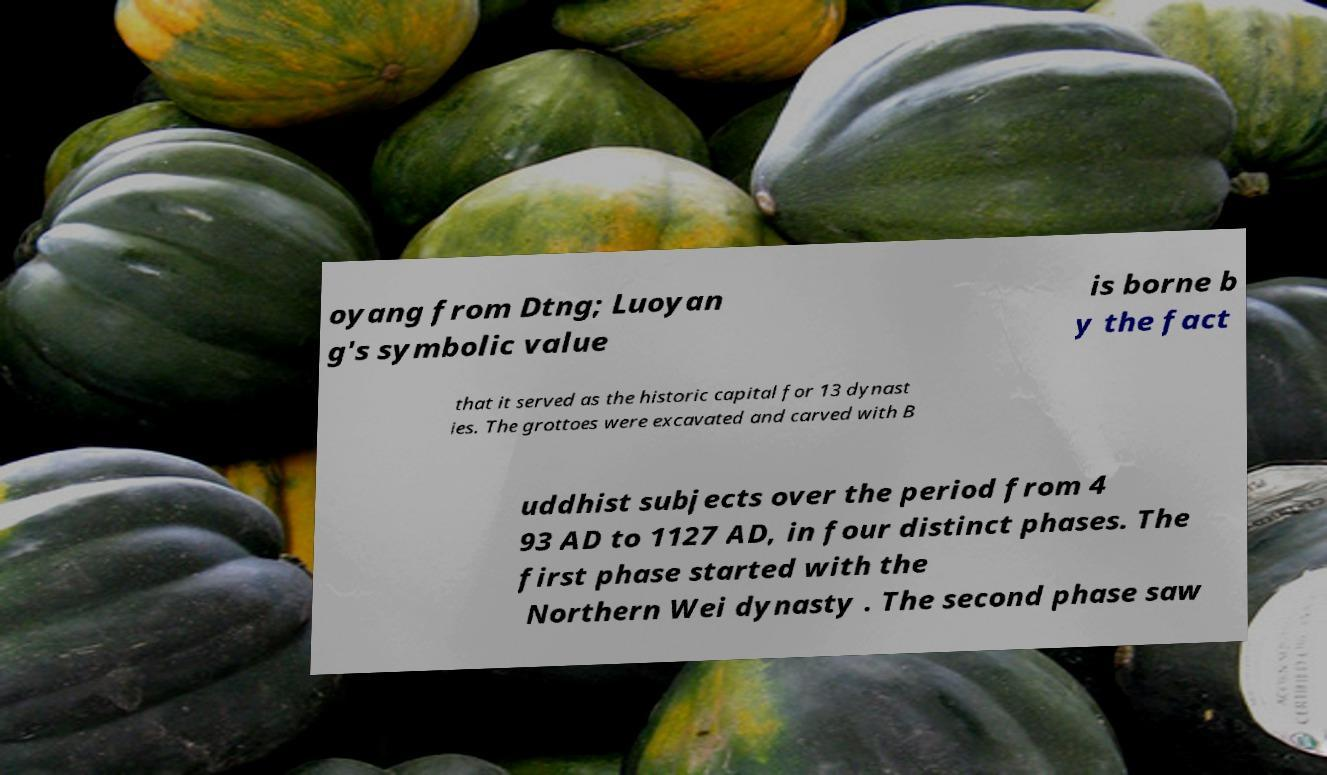There's text embedded in this image that I need extracted. Can you transcribe it verbatim? oyang from Dtng; Luoyan g's symbolic value is borne b y the fact that it served as the historic capital for 13 dynast ies. The grottoes were excavated and carved with B uddhist subjects over the period from 4 93 AD to 1127 AD, in four distinct phases. The first phase started with the Northern Wei dynasty . The second phase saw 